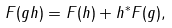Convert formula to latex. <formula><loc_0><loc_0><loc_500><loc_500>\label l { e q \colon c r h } F ( g h ) = F ( h ) + h ^ { * } F ( g ) ,</formula> 